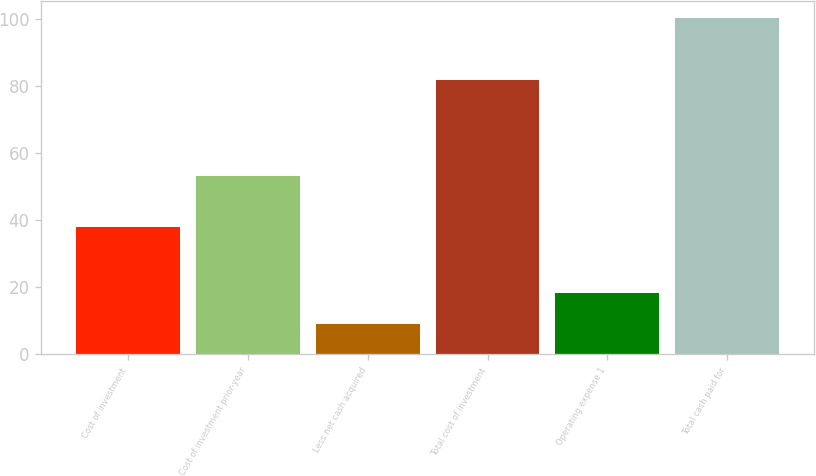Convert chart. <chart><loc_0><loc_0><loc_500><loc_500><bar_chart><fcel>Cost of investment<fcel>Cost of investment prior-year<fcel>Less net cash acquired<fcel>Total cost of investment<fcel>Operating expense 1<fcel>Total cash paid for<nl><fcel>37.8<fcel>53.1<fcel>9.2<fcel>81.7<fcel>18.4<fcel>100.1<nl></chart> 